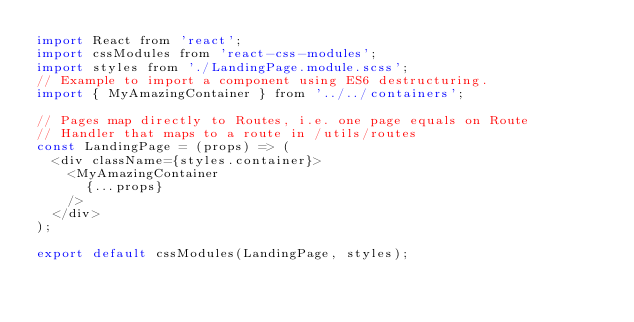Convert code to text. <code><loc_0><loc_0><loc_500><loc_500><_JavaScript_>import React from 'react';
import cssModules from 'react-css-modules';
import styles from './LandingPage.module.scss';
// Example to import a component using ES6 destructuring.
import { MyAmazingContainer } from '../../containers';

// Pages map directly to Routes, i.e. one page equals on Route
// Handler that maps to a route in /utils/routes
const LandingPage = (props) => (
  <div className={styles.container}>
    <MyAmazingContainer
      {...props}
    />
  </div>
);

export default cssModules(LandingPage, styles);
</code> 